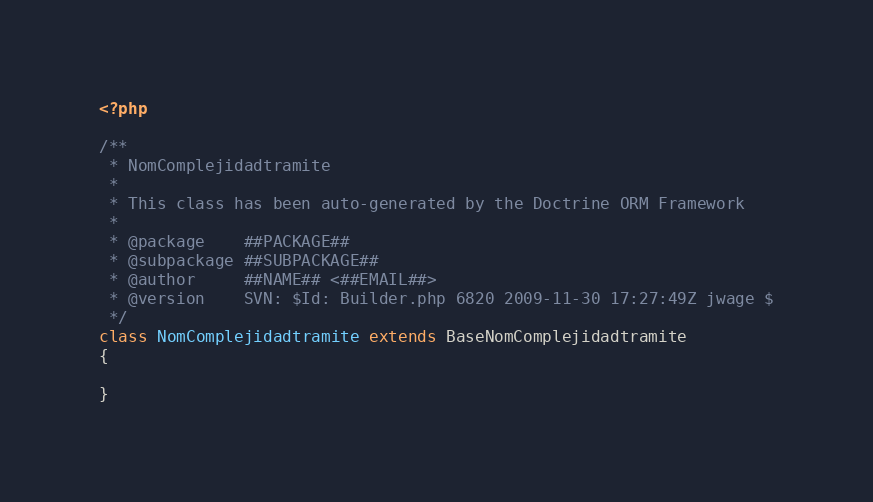Convert code to text. <code><loc_0><loc_0><loc_500><loc_500><_PHP_><?php

/**
 * NomComplejidadtramite
 * 
 * This class has been auto-generated by the Doctrine ORM Framework
 * 
 * @package    ##PACKAGE##
 * @subpackage ##SUBPACKAGE##
 * @author     ##NAME## <##EMAIL##>
 * @version    SVN: $Id: Builder.php 6820 2009-11-30 17:27:49Z jwage $
 */
class NomComplejidadtramite extends BaseNomComplejidadtramite
{

}</code> 